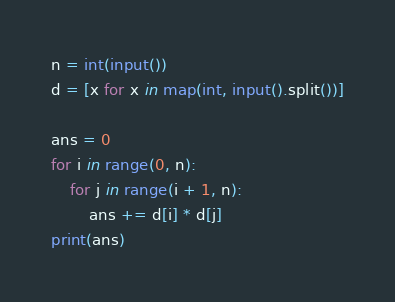Convert code to text. <code><loc_0><loc_0><loc_500><loc_500><_Python_>n = int(input())
d = [x for x in map(int, input().split())]

ans = 0
for i in range(0, n):
    for j in range(i + 1, n):
        ans += d[i] * d[j]
print(ans)
</code> 